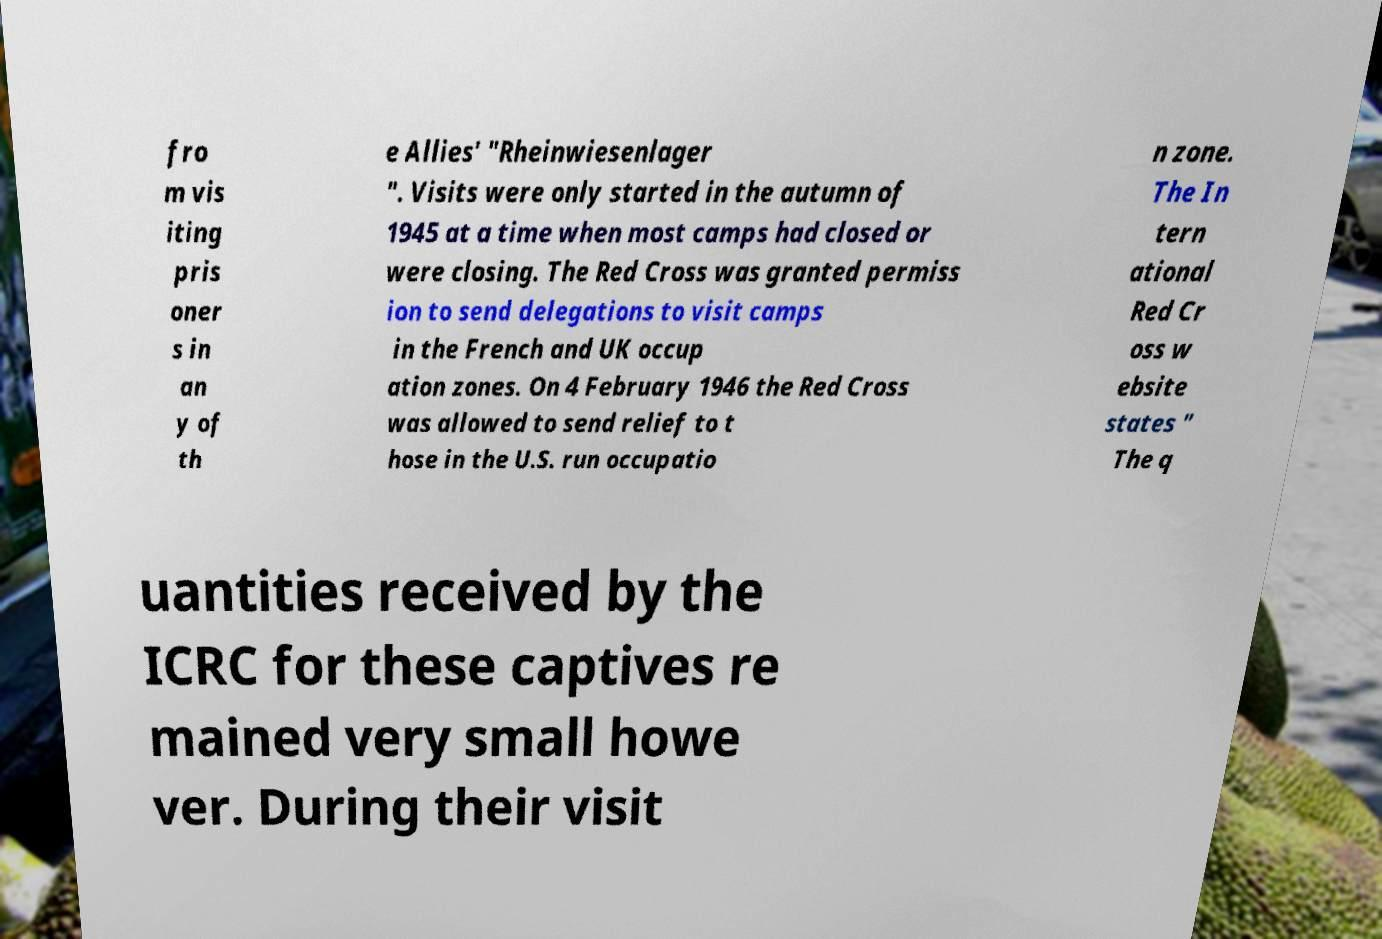Could you extract and type out the text from this image? fro m vis iting pris oner s in an y of th e Allies' "Rheinwiesenlager ". Visits were only started in the autumn of 1945 at a time when most camps had closed or were closing. The Red Cross was granted permiss ion to send delegations to visit camps in the French and UK occup ation zones. On 4 February 1946 the Red Cross was allowed to send relief to t hose in the U.S. run occupatio n zone. The In tern ational Red Cr oss w ebsite states " The q uantities received by the ICRC for these captives re mained very small howe ver. During their visit 